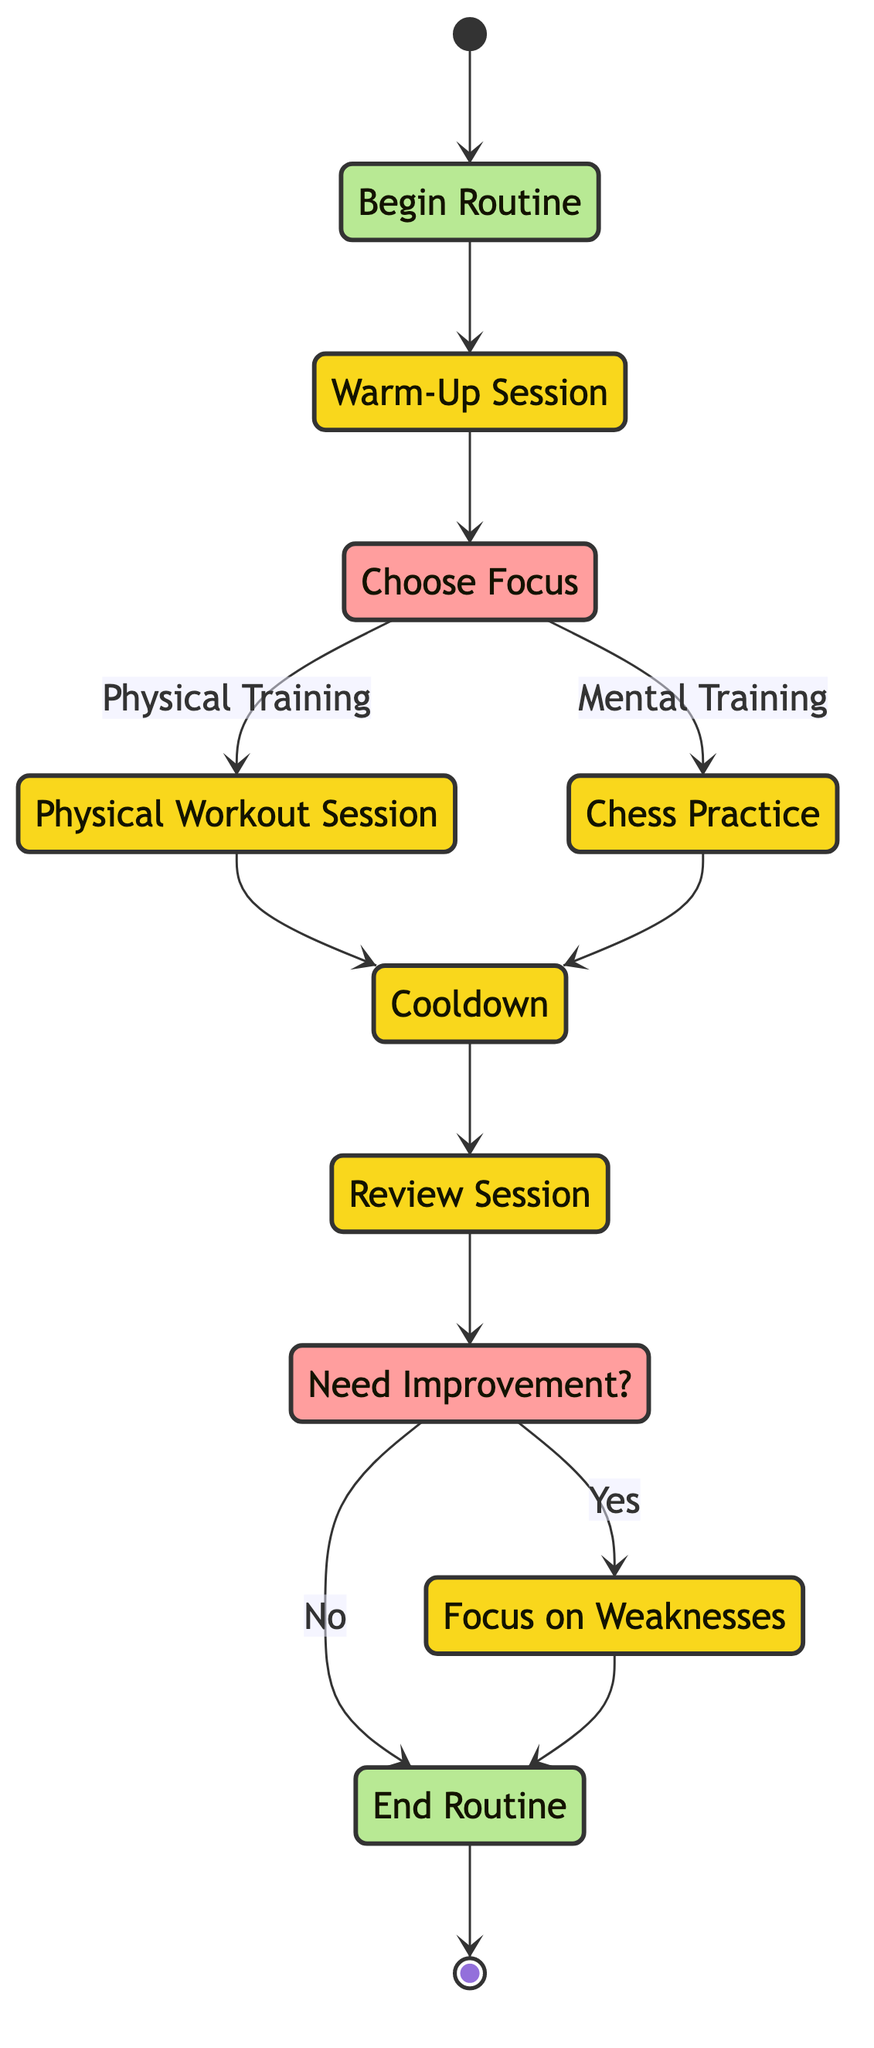What is the first activity in the routine? The diagram starts with the 'Begin Routine' node, and the first activity that follows it is the 'Warm-Up Session'.
Answer: Warm-Up Session How many decision points are in the diagram? There are two decision points: 'Choose Focus' and 'Need Improvement?'. Both points lead to different pathways based on choices made.
Answer: 2 What activity directly follows the Chess Practice? After engaging in 'Chess Practice', the next activity is the 'Cooldown', which is a relaxing phase after mental training.
Answer: Cooldown What must be completed before the Review Session? The activities that must be completed before the 'Review Session' are either 'Physical Workout Session' or 'Chess Practice', leading into cooldown.
Answer: Cooldown If 'Need Improvement?' is answered with 'Yes', what is the next activity? If 'Need Improvement?' receives a 'Yes', the diagram indicates a transition to the 'Focus on Weaknesses' activity to address identified areas for improvement.
Answer: Focus on Weaknesses What happens if 'Need Improvement?' is answered with 'No'? Choosing 'No' in the decision node 'Need Improvement?' leads directly to the 'End Routine', signaling the conclusion of the activities.
Answer: End Routine How many activities are included in the total routine? The total activities in the routine consist of six different nodes: 'Warm-Up Session', 'Physical Workout Session', 'Chess Practice', 'Cooldown', 'Review Session', and 'Focus on Weaknesses'.
Answer: 6 Which option is chosen if one decides to emphasize mental training? If the individual decides to prioritize mental training, they will select 'Mental Training', which leads to the 'Chess Practice'.
Answer: Chess Practice What activity signifies the start of the routine? The start of the routine is signified by the 'Begin Routine' node, marking the initiation of the entire process.
Answer: Begin Routine 